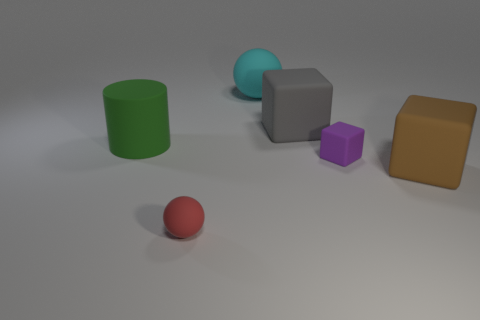Add 4 large brown matte objects. How many objects exist? 10 Subtract all cylinders. How many objects are left? 5 Subtract 0 red cubes. How many objects are left? 6 Subtract all tiny balls. Subtract all purple matte objects. How many objects are left? 4 Add 1 small red things. How many small red things are left? 2 Add 1 small objects. How many small objects exist? 3 